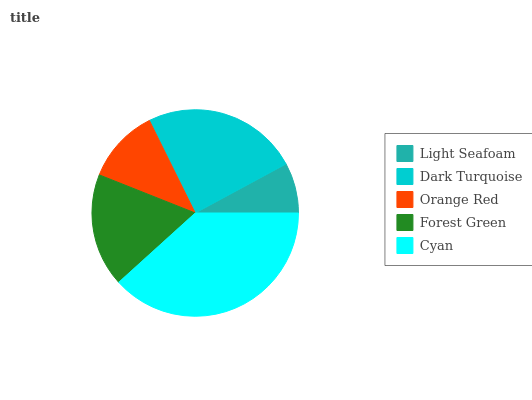Is Light Seafoam the minimum?
Answer yes or no. Yes. Is Cyan the maximum?
Answer yes or no. Yes. Is Dark Turquoise the minimum?
Answer yes or no. No. Is Dark Turquoise the maximum?
Answer yes or no. No. Is Dark Turquoise greater than Light Seafoam?
Answer yes or no. Yes. Is Light Seafoam less than Dark Turquoise?
Answer yes or no. Yes. Is Light Seafoam greater than Dark Turquoise?
Answer yes or no. No. Is Dark Turquoise less than Light Seafoam?
Answer yes or no. No. Is Forest Green the high median?
Answer yes or no. Yes. Is Forest Green the low median?
Answer yes or no. Yes. Is Cyan the high median?
Answer yes or no. No. Is Dark Turquoise the low median?
Answer yes or no. No. 